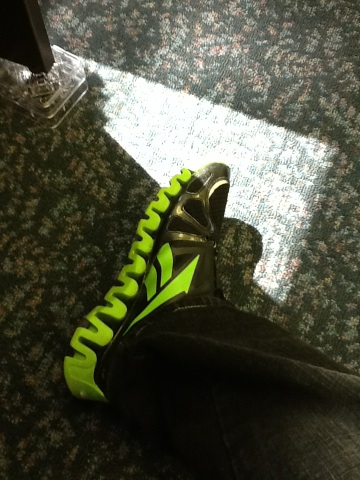Can you tell me more about the style of these shoes? Certainly! The shoes have a unique, futuristic design characterized by zigzag patterns on the green sole, which might suggest they are designed for specific sports or activities that require good grip and traction. The overall style combines both functionality and a bold aesthetic appeal. 